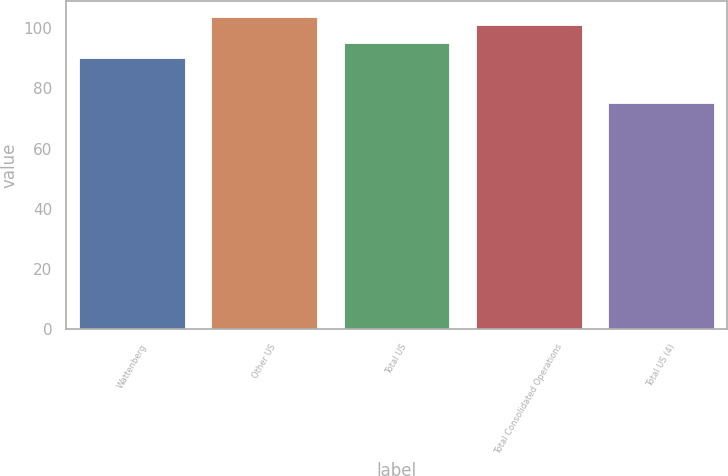Convert chart. <chart><loc_0><loc_0><loc_500><loc_500><bar_chart><fcel>Wattenberg<fcel>Other US<fcel>Total US<fcel>Total Consolidated Operations<fcel>Total US (4)<nl><fcel>90.05<fcel>103.76<fcel>95.19<fcel>100.93<fcel>75.03<nl></chart> 